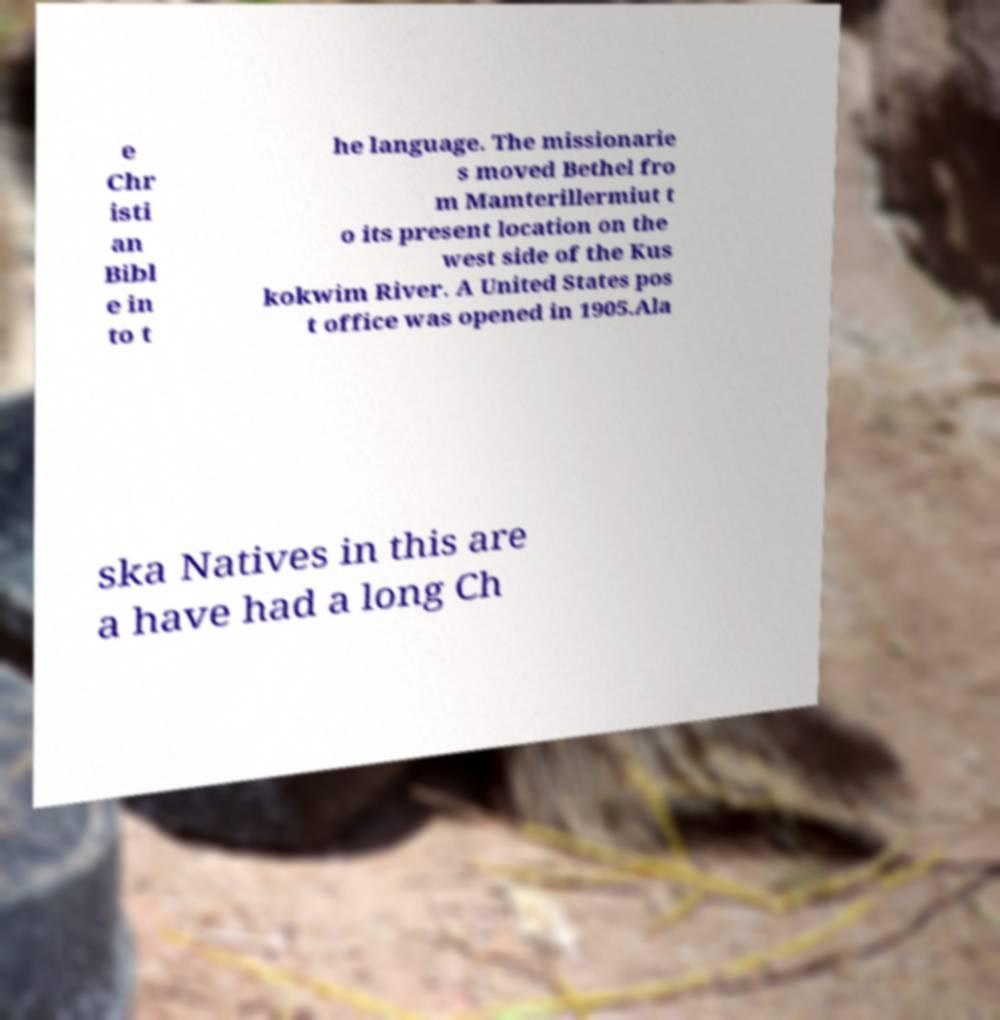Could you extract and type out the text from this image? e Chr isti an Bibl e in to t he language. The missionarie s moved Bethel fro m Mamterillermiut t o its present location on the west side of the Kus kokwim River. A United States pos t office was opened in 1905.Ala ska Natives in this are a have had a long Ch 